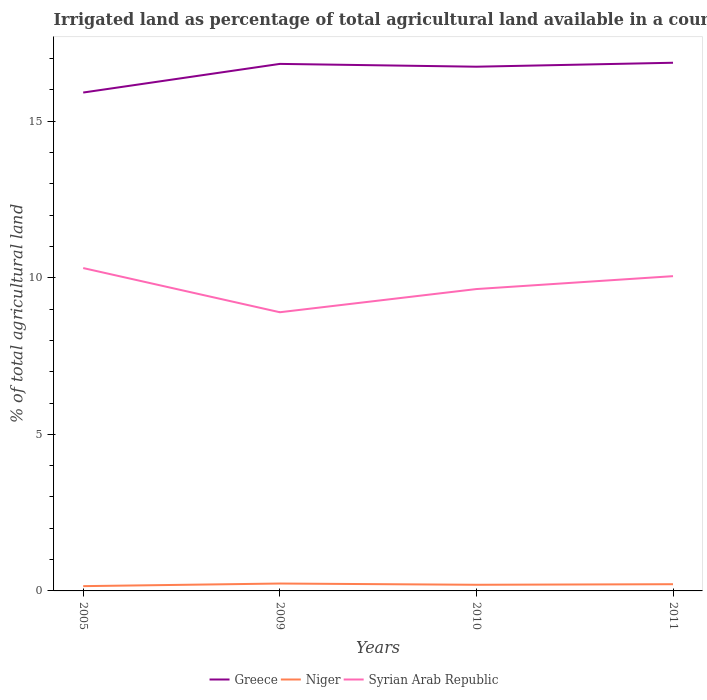How many different coloured lines are there?
Your answer should be very brief. 3. Across all years, what is the maximum percentage of irrigated land in Syrian Arab Republic?
Make the answer very short. 8.9. What is the total percentage of irrigated land in Syrian Arab Republic in the graph?
Ensure brevity in your answer.  -0.41. What is the difference between the highest and the second highest percentage of irrigated land in Niger?
Provide a succinct answer. 0.08. Is the percentage of irrigated land in Niger strictly greater than the percentage of irrigated land in Greece over the years?
Give a very brief answer. Yes. How many years are there in the graph?
Offer a terse response. 4. What is the difference between two consecutive major ticks on the Y-axis?
Provide a short and direct response. 5. Does the graph contain any zero values?
Ensure brevity in your answer.  No. How are the legend labels stacked?
Your answer should be compact. Horizontal. What is the title of the graph?
Your answer should be compact. Irrigated land as percentage of total agricultural land available in a country. What is the label or title of the X-axis?
Provide a short and direct response. Years. What is the label or title of the Y-axis?
Keep it short and to the point. % of total agricultural land. What is the % of total agricultural land in Greece in 2005?
Provide a succinct answer. 15.92. What is the % of total agricultural land of Niger in 2005?
Your answer should be very brief. 0.15. What is the % of total agricultural land of Syrian Arab Republic in 2005?
Offer a terse response. 10.31. What is the % of total agricultural land in Greece in 2009?
Your answer should be very brief. 16.83. What is the % of total agricultural land in Niger in 2009?
Make the answer very short. 0.24. What is the % of total agricultural land of Syrian Arab Republic in 2009?
Keep it short and to the point. 8.9. What is the % of total agricultural land of Greece in 2010?
Offer a very short reply. 16.74. What is the % of total agricultural land of Niger in 2010?
Keep it short and to the point. 0.2. What is the % of total agricultural land in Syrian Arab Republic in 2010?
Ensure brevity in your answer.  9.64. What is the % of total agricultural land in Greece in 2011?
Provide a short and direct response. 16.87. What is the % of total agricultural land in Niger in 2011?
Provide a short and direct response. 0.21. What is the % of total agricultural land in Syrian Arab Republic in 2011?
Offer a terse response. 10.05. Across all years, what is the maximum % of total agricultural land in Greece?
Your answer should be compact. 16.87. Across all years, what is the maximum % of total agricultural land in Niger?
Your answer should be very brief. 0.24. Across all years, what is the maximum % of total agricultural land in Syrian Arab Republic?
Your answer should be very brief. 10.31. Across all years, what is the minimum % of total agricultural land in Greece?
Ensure brevity in your answer.  15.92. Across all years, what is the minimum % of total agricultural land in Niger?
Your response must be concise. 0.15. Across all years, what is the minimum % of total agricultural land of Syrian Arab Republic?
Offer a terse response. 8.9. What is the total % of total agricultural land of Greece in the graph?
Make the answer very short. 66.37. What is the total % of total agricultural land in Niger in the graph?
Give a very brief answer. 0.8. What is the total % of total agricultural land of Syrian Arab Republic in the graph?
Your answer should be very brief. 38.91. What is the difference between the % of total agricultural land of Greece in 2005 and that in 2009?
Offer a terse response. -0.92. What is the difference between the % of total agricultural land in Niger in 2005 and that in 2009?
Offer a terse response. -0.08. What is the difference between the % of total agricultural land of Syrian Arab Republic in 2005 and that in 2009?
Provide a succinct answer. 1.41. What is the difference between the % of total agricultural land in Greece in 2005 and that in 2010?
Provide a short and direct response. -0.83. What is the difference between the % of total agricultural land of Niger in 2005 and that in 2010?
Offer a very short reply. -0.04. What is the difference between the % of total agricultural land of Syrian Arab Republic in 2005 and that in 2010?
Keep it short and to the point. 0.67. What is the difference between the % of total agricultural land of Greece in 2005 and that in 2011?
Provide a short and direct response. -0.95. What is the difference between the % of total agricultural land in Niger in 2005 and that in 2011?
Your response must be concise. -0.06. What is the difference between the % of total agricultural land of Syrian Arab Republic in 2005 and that in 2011?
Make the answer very short. 0.26. What is the difference between the % of total agricultural land in Greece in 2009 and that in 2010?
Make the answer very short. 0.09. What is the difference between the % of total agricultural land in Niger in 2009 and that in 2010?
Make the answer very short. 0.04. What is the difference between the % of total agricultural land of Syrian Arab Republic in 2009 and that in 2010?
Keep it short and to the point. -0.74. What is the difference between the % of total agricultural land of Greece in 2009 and that in 2011?
Keep it short and to the point. -0.04. What is the difference between the % of total agricultural land in Niger in 2009 and that in 2011?
Your response must be concise. 0.02. What is the difference between the % of total agricultural land in Syrian Arab Republic in 2009 and that in 2011?
Offer a terse response. -1.15. What is the difference between the % of total agricultural land of Greece in 2010 and that in 2011?
Keep it short and to the point. -0.13. What is the difference between the % of total agricultural land in Niger in 2010 and that in 2011?
Give a very brief answer. -0.02. What is the difference between the % of total agricultural land of Syrian Arab Republic in 2010 and that in 2011?
Keep it short and to the point. -0.41. What is the difference between the % of total agricultural land of Greece in 2005 and the % of total agricultural land of Niger in 2009?
Your answer should be very brief. 15.68. What is the difference between the % of total agricultural land of Greece in 2005 and the % of total agricultural land of Syrian Arab Republic in 2009?
Give a very brief answer. 7.02. What is the difference between the % of total agricultural land of Niger in 2005 and the % of total agricultural land of Syrian Arab Republic in 2009?
Give a very brief answer. -8.75. What is the difference between the % of total agricultural land in Greece in 2005 and the % of total agricultural land in Niger in 2010?
Your answer should be very brief. 15.72. What is the difference between the % of total agricultural land in Greece in 2005 and the % of total agricultural land in Syrian Arab Republic in 2010?
Offer a terse response. 6.28. What is the difference between the % of total agricultural land of Niger in 2005 and the % of total agricultural land of Syrian Arab Republic in 2010?
Your answer should be very brief. -9.49. What is the difference between the % of total agricultural land in Greece in 2005 and the % of total agricultural land in Niger in 2011?
Ensure brevity in your answer.  15.7. What is the difference between the % of total agricultural land of Greece in 2005 and the % of total agricultural land of Syrian Arab Republic in 2011?
Offer a very short reply. 5.86. What is the difference between the % of total agricultural land in Niger in 2005 and the % of total agricultural land in Syrian Arab Republic in 2011?
Your response must be concise. -9.9. What is the difference between the % of total agricultural land in Greece in 2009 and the % of total agricultural land in Niger in 2010?
Make the answer very short. 16.64. What is the difference between the % of total agricultural land in Greece in 2009 and the % of total agricultural land in Syrian Arab Republic in 2010?
Offer a very short reply. 7.19. What is the difference between the % of total agricultural land in Niger in 2009 and the % of total agricultural land in Syrian Arab Republic in 2010?
Your answer should be compact. -9.41. What is the difference between the % of total agricultural land of Greece in 2009 and the % of total agricultural land of Niger in 2011?
Provide a succinct answer. 16.62. What is the difference between the % of total agricultural land of Greece in 2009 and the % of total agricultural land of Syrian Arab Republic in 2011?
Your answer should be very brief. 6.78. What is the difference between the % of total agricultural land of Niger in 2009 and the % of total agricultural land of Syrian Arab Republic in 2011?
Offer a very short reply. -9.82. What is the difference between the % of total agricultural land of Greece in 2010 and the % of total agricultural land of Niger in 2011?
Give a very brief answer. 16.53. What is the difference between the % of total agricultural land of Greece in 2010 and the % of total agricultural land of Syrian Arab Republic in 2011?
Ensure brevity in your answer.  6.69. What is the difference between the % of total agricultural land of Niger in 2010 and the % of total agricultural land of Syrian Arab Republic in 2011?
Provide a short and direct response. -9.86. What is the average % of total agricultural land of Greece per year?
Make the answer very short. 16.59. What is the average % of total agricultural land of Niger per year?
Make the answer very short. 0.2. What is the average % of total agricultural land of Syrian Arab Republic per year?
Offer a very short reply. 9.73. In the year 2005, what is the difference between the % of total agricultural land of Greece and % of total agricultural land of Niger?
Your answer should be very brief. 15.77. In the year 2005, what is the difference between the % of total agricultural land of Greece and % of total agricultural land of Syrian Arab Republic?
Make the answer very short. 5.61. In the year 2005, what is the difference between the % of total agricultural land in Niger and % of total agricultural land in Syrian Arab Republic?
Make the answer very short. -10.16. In the year 2009, what is the difference between the % of total agricultural land of Greece and % of total agricultural land of Niger?
Make the answer very short. 16.6. In the year 2009, what is the difference between the % of total agricultural land in Greece and % of total agricultural land in Syrian Arab Republic?
Offer a terse response. 7.93. In the year 2009, what is the difference between the % of total agricultural land in Niger and % of total agricultural land in Syrian Arab Republic?
Keep it short and to the point. -8.67. In the year 2010, what is the difference between the % of total agricultural land of Greece and % of total agricultural land of Niger?
Give a very brief answer. 16.55. In the year 2010, what is the difference between the % of total agricultural land of Greece and % of total agricultural land of Syrian Arab Republic?
Your answer should be very brief. 7.1. In the year 2010, what is the difference between the % of total agricultural land of Niger and % of total agricultural land of Syrian Arab Republic?
Make the answer very short. -9.45. In the year 2011, what is the difference between the % of total agricultural land in Greece and % of total agricultural land in Niger?
Offer a terse response. 16.66. In the year 2011, what is the difference between the % of total agricultural land in Greece and % of total agricultural land in Syrian Arab Republic?
Your answer should be very brief. 6.82. In the year 2011, what is the difference between the % of total agricultural land in Niger and % of total agricultural land in Syrian Arab Republic?
Ensure brevity in your answer.  -9.84. What is the ratio of the % of total agricultural land of Greece in 2005 to that in 2009?
Ensure brevity in your answer.  0.95. What is the ratio of the % of total agricultural land in Niger in 2005 to that in 2009?
Offer a terse response. 0.65. What is the ratio of the % of total agricultural land of Syrian Arab Republic in 2005 to that in 2009?
Keep it short and to the point. 1.16. What is the ratio of the % of total agricultural land in Greece in 2005 to that in 2010?
Provide a succinct answer. 0.95. What is the ratio of the % of total agricultural land of Niger in 2005 to that in 2010?
Offer a terse response. 0.78. What is the ratio of the % of total agricultural land of Syrian Arab Republic in 2005 to that in 2010?
Offer a terse response. 1.07. What is the ratio of the % of total agricultural land in Greece in 2005 to that in 2011?
Your response must be concise. 0.94. What is the ratio of the % of total agricultural land of Niger in 2005 to that in 2011?
Offer a terse response. 0.71. What is the ratio of the % of total agricultural land in Syrian Arab Republic in 2005 to that in 2011?
Make the answer very short. 1.03. What is the ratio of the % of total agricultural land in Greece in 2009 to that in 2010?
Offer a very short reply. 1.01. What is the ratio of the % of total agricultural land in Niger in 2009 to that in 2010?
Make the answer very short. 1.21. What is the ratio of the % of total agricultural land of Syrian Arab Republic in 2009 to that in 2010?
Your answer should be compact. 0.92. What is the ratio of the % of total agricultural land of Niger in 2009 to that in 2011?
Make the answer very short. 1.1. What is the ratio of the % of total agricultural land in Syrian Arab Republic in 2009 to that in 2011?
Offer a very short reply. 0.89. What is the ratio of the % of total agricultural land of Niger in 2010 to that in 2011?
Your answer should be very brief. 0.91. What is the ratio of the % of total agricultural land in Syrian Arab Republic in 2010 to that in 2011?
Give a very brief answer. 0.96. What is the difference between the highest and the second highest % of total agricultural land in Greece?
Your response must be concise. 0.04. What is the difference between the highest and the second highest % of total agricultural land in Niger?
Your answer should be compact. 0.02. What is the difference between the highest and the second highest % of total agricultural land in Syrian Arab Republic?
Keep it short and to the point. 0.26. What is the difference between the highest and the lowest % of total agricultural land of Greece?
Provide a short and direct response. 0.95. What is the difference between the highest and the lowest % of total agricultural land in Niger?
Keep it short and to the point. 0.08. What is the difference between the highest and the lowest % of total agricultural land in Syrian Arab Republic?
Offer a very short reply. 1.41. 